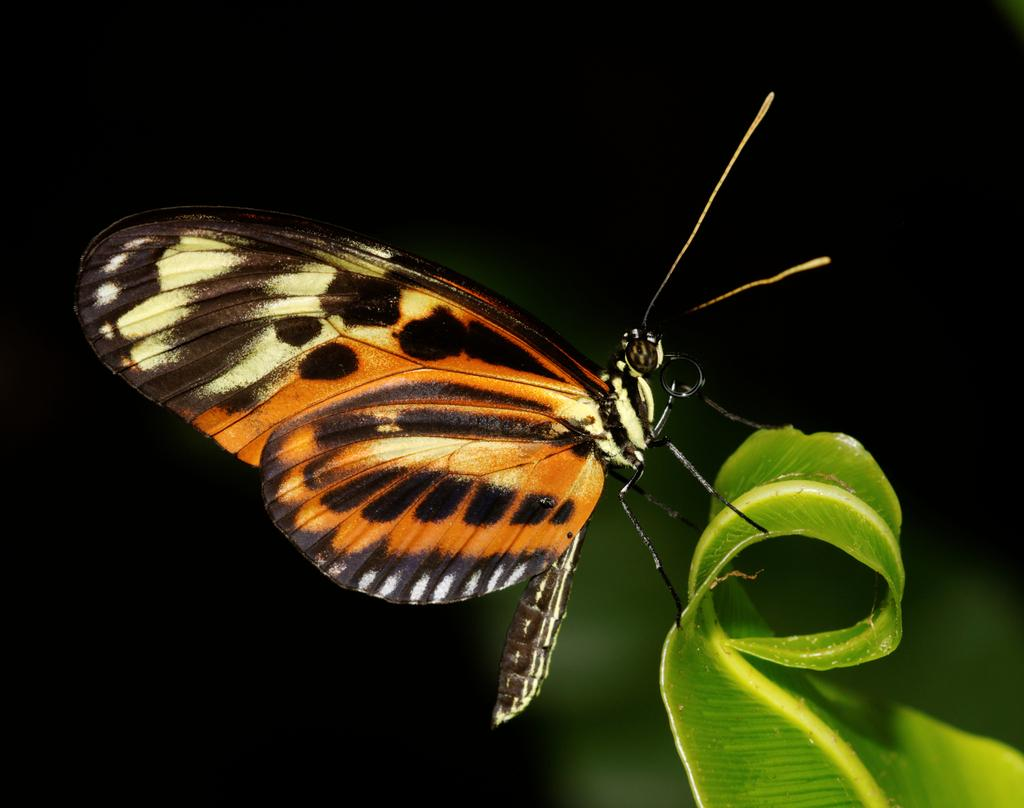What is the main subject of the image? The main subject of the image is a butterfly. Where is the butterfly located in the image? The butterfly is on a leaf in the image. What are the butterfly's hobbies in the image? Butterflies do not have hobbies, and there is no information about the butterfly's activities in the image. 